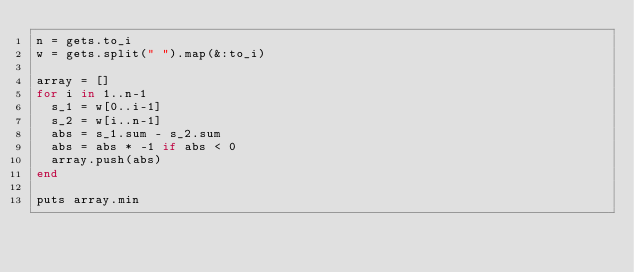<code> <loc_0><loc_0><loc_500><loc_500><_Ruby_>n = gets.to_i
w = gets.split(" ").map(&:to_i)

array = []
for i in 1..n-1
  s_1 = w[0..i-1]
  s_2 = w[i..n-1]
  abs = s_1.sum - s_2.sum
  abs = abs * -1 if abs < 0
  array.push(abs)
end

puts array.min</code> 